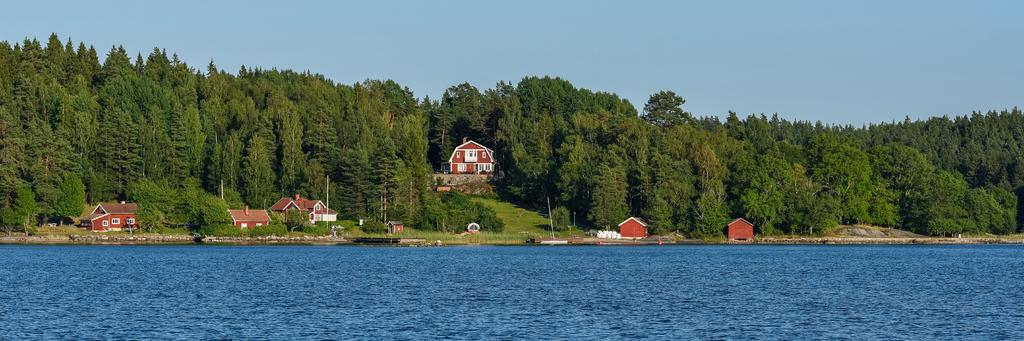What type of structures can be seen in the image? There are houses in the image. What type of vegetation is present in the image? There are many trees and grass visible in the image. What part of the natural environment is visible in the image? The sky is visible at the top of the image, and water is visible at the bottom of the image. Can you see a fingerprint on the scarecrow in the image? There is no scarecrow present in the image, and therefore no fingerprint can be observed. What type of river is flowing through the image? There is no river present in the image; it features houses, trees, grass, sky, and water. 